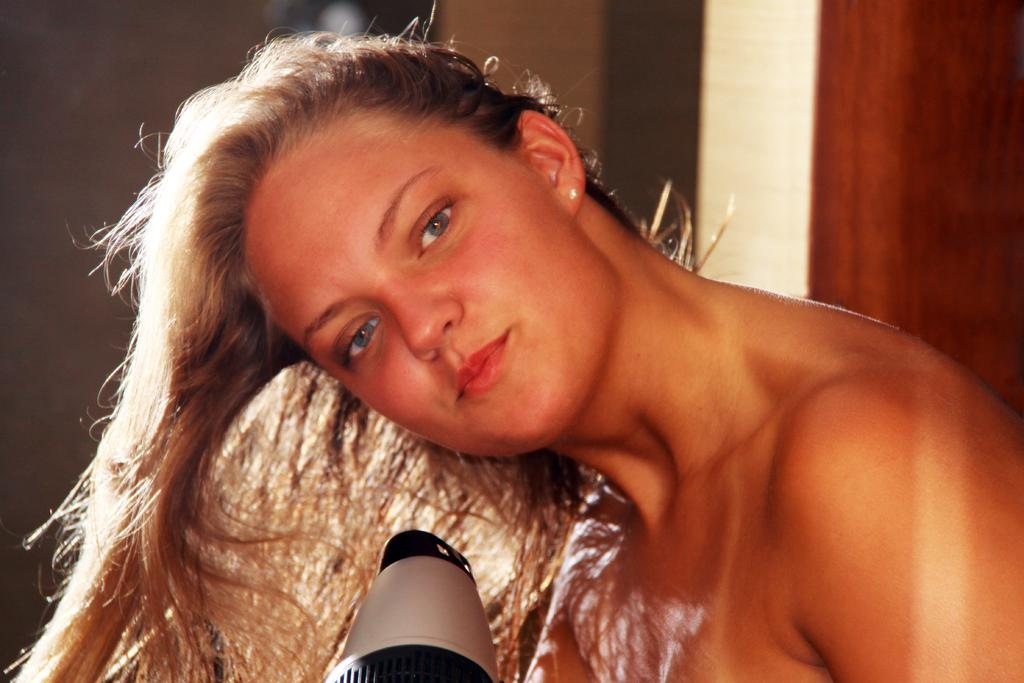Who is present in the image? There is a woman in the image. What is the woman doing in the image? The woman is blowing her hair. What can be seen in the background of the image? There is a wall and a door in the background of the image. What type of drum can be heard in the image? There is no drum present in the image, and therefore no sound can be heard. 